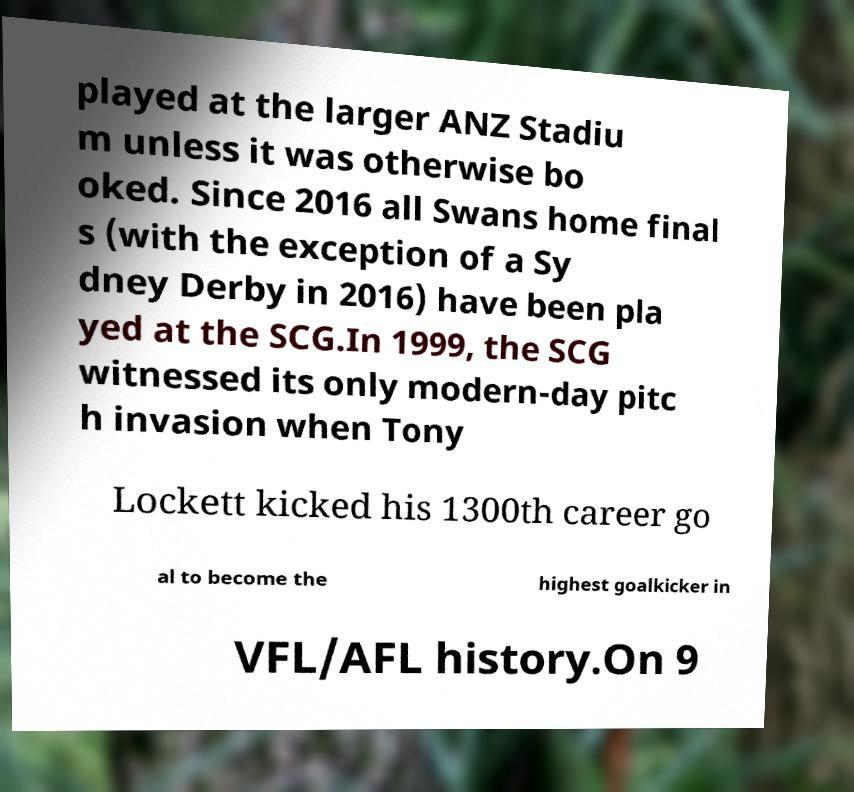There's text embedded in this image that I need extracted. Can you transcribe it verbatim? played at the larger ANZ Stadiu m unless it was otherwise bo oked. Since 2016 all Swans home final s (with the exception of a Sy dney Derby in 2016) have been pla yed at the SCG.In 1999, the SCG witnessed its only modern-day pitc h invasion when Tony Lockett kicked his 1300th career go al to become the highest goalkicker in VFL/AFL history.On 9 